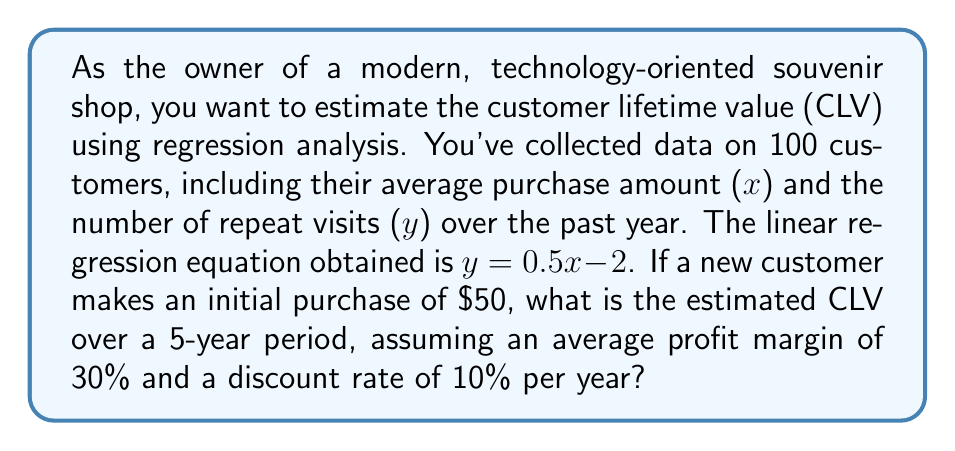Teach me how to tackle this problem. 1. First, we need to estimate the number of repeat visits for a customer with an initial purchase of $50:
   $y = 0.5x - 2$
   $y = 0.5(50) - 2 = 23$ repeat visits per year

2. Total visits per year = initial visit + repeat visits = 1 + 23 = 24 visits

3. Calculate the annual revenue:
   Annual revenue = Number of visits × Average purchase amount
   Annual revenue = 24 × $50 = $1,200

4. Calculate the annual profit:
   Annual profit = Annual revenue × Profit margin
   Annual profit = $1,200 × 0.30 = $360

5. To calculate the CLV over 5 years, we need to discount future profits:
   $$CLV = \sum_{t=1}^{5} \frac{Annual Profit}{(1 + Discount Rate)^t}$$

   $$CLV = \frac{360}{(1 + 0.10)^1} + \frac{360}{(1 + 0.10)^2} + \frac{360}{(1 + 0.10)^3} + \frac{360}{(1 + 0.10)^4} + \frac{360}{(1 + 0.10)^5}$$

6. Calculating each term:
   Year 1: $\frac{360}{1.10} = 327.27$
   Year 2: $\frac{360}{1.21} = 297.52$
   Year 3: $\frac{360}{1.331} = 270.47$
   Year 4: $\frac{360}{1.4641} = 245.88$
   Year 5: $\frac{360}{1.61051} = 223.53$

7. Sum up all the discounted profits:
   CLV = 327.27 + 297.52 + 270.47 + 245.88 + 223.53 = $1,364.67
Answer: $1,364.67 